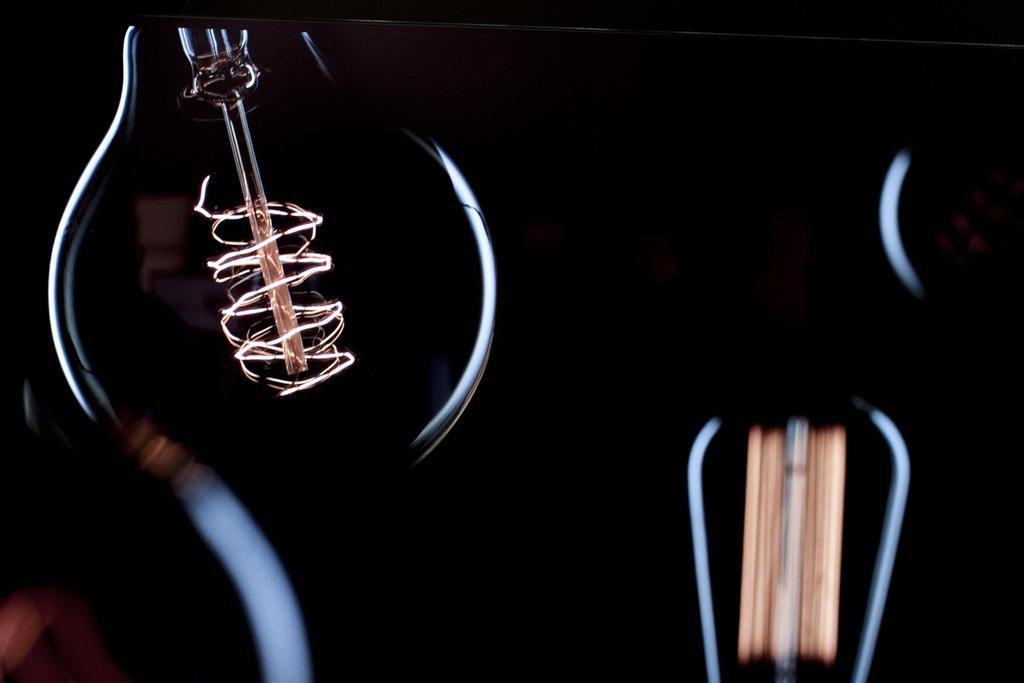Please provide a concise description of this image. In this picture we can see bulb, mostly it is dark. The picture looks like it is edited. In this picture there is filament also. 